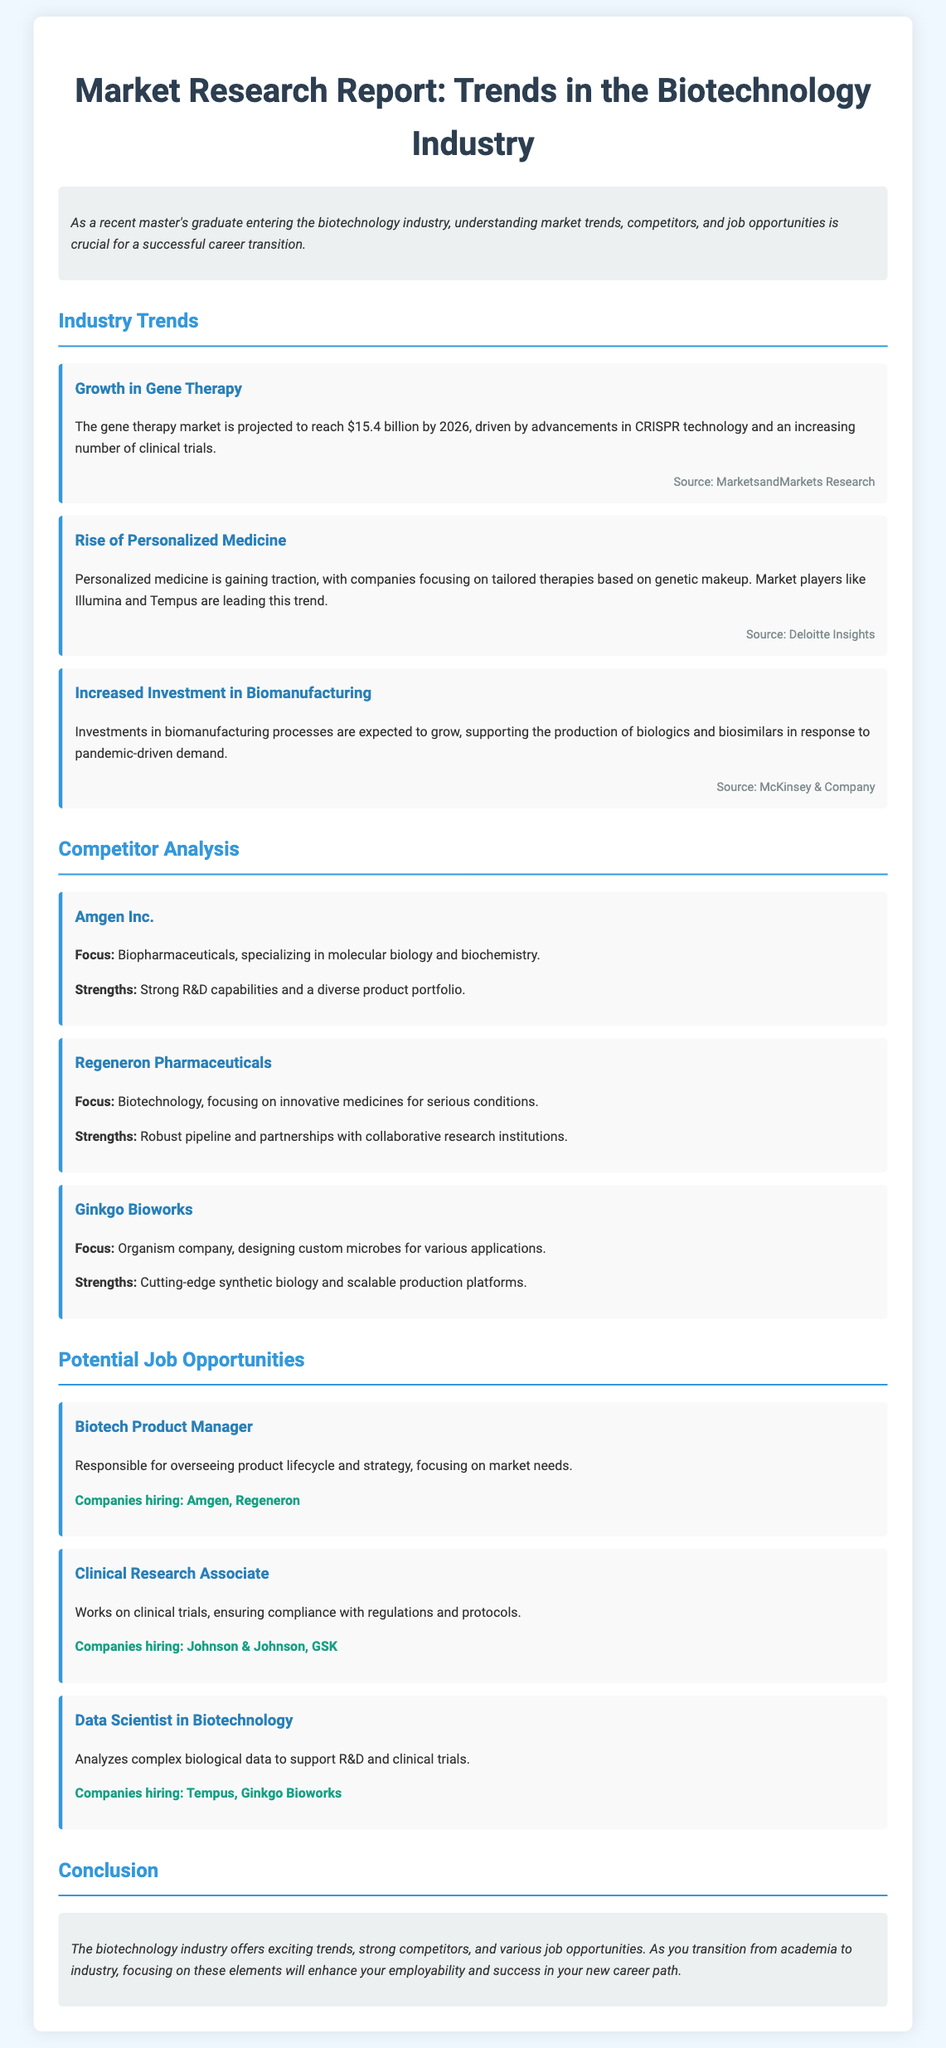What is the projected size of the gene therapy market by 2026? The document states the gene therapy market is projected to reach $15.4 billion by 2026.
Answer: $15.4 billion Which company focuses on molecular biology and biochemistry? According to the competitor analysis, Amgen Inc. specializes in molecular biology and biochemistry.
Answer: Amgen Inc What trend is highlighted regarding personalized medicine? The report mentions that personalized medicine is gaining traction, with a focus on tailored therapies based on genetic makeup.
Answer: Tailored therapies based on genetic makeup Which companies are hiring for the Clinical Research Associate position? The document lists Johnson & Johnson and GSK as companies hiring for this role.
Answer: Johnson & Johnson, GSK What is a major focus area for Ginkgo Bioworks? The document describes Ginkgo Bioworks as designing custom microbes for various applications.
Answer: Custom microbes How is the biotechnology industry described in the conclusion? The conclusion states that the biotechnology industry offers exciting trends, strong competitors, and various job opportunities.
Answer: Exciting trends, strong competitors, various job opportunities What is the focus of increased investment mentioned in the trends? The trends point out increased investment in biomanufacturing processes related to the production of biologics and biosimilars.
Answer: Biologics and biosimilars Which company is noted as a leader in advancements in CRISPR technology? The industry trend indicates advancements in CRISPR technology are driving the growth in gene therapy.
Answer: CRISPR technology 